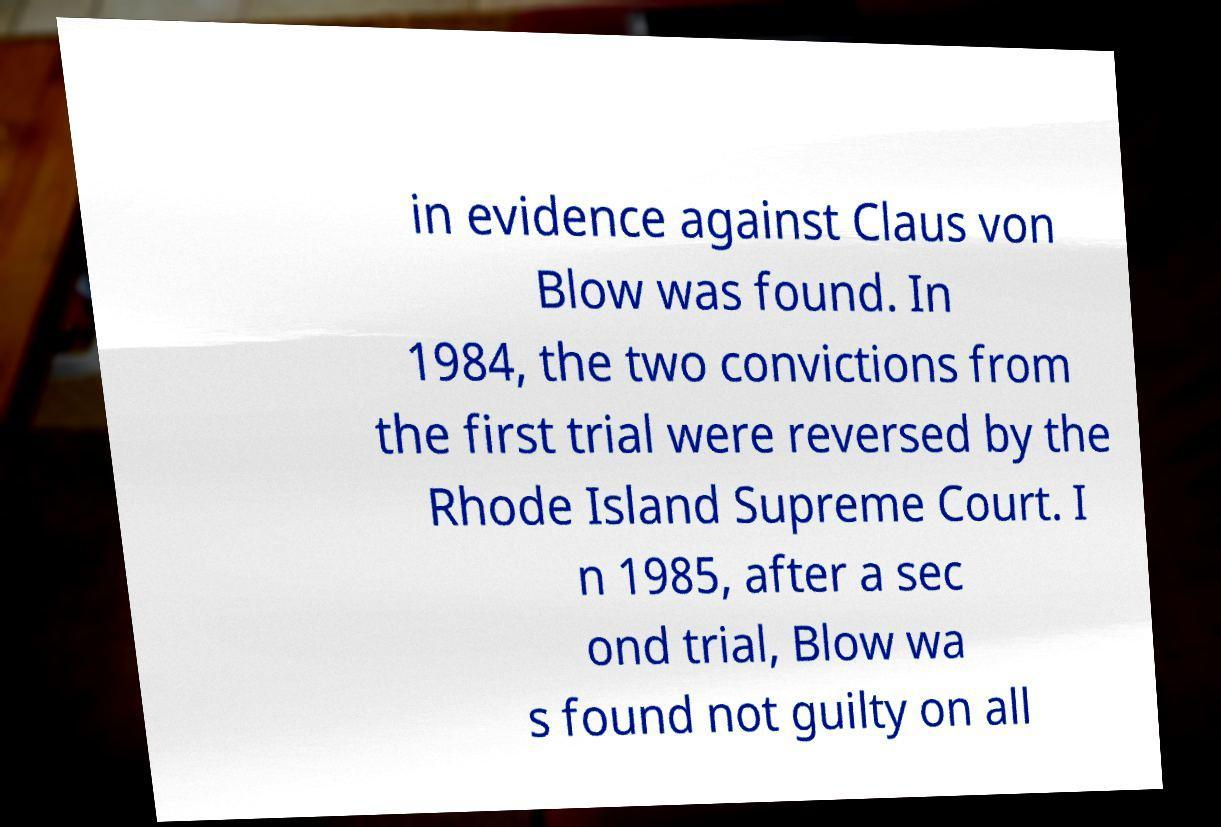What messages or text are displayed in this image? I need them in a readable, typed format. in evidence against Claus von Blow was found. In 1984, the two convictions from the first trial were reversed by the Rhode Island Supreme Court. I n 1985, after a sec ond trial, Blow wa s found not guilty on all 